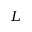<formula> <loc_0><loc_0><loc_500><loc_500>L</formula> 